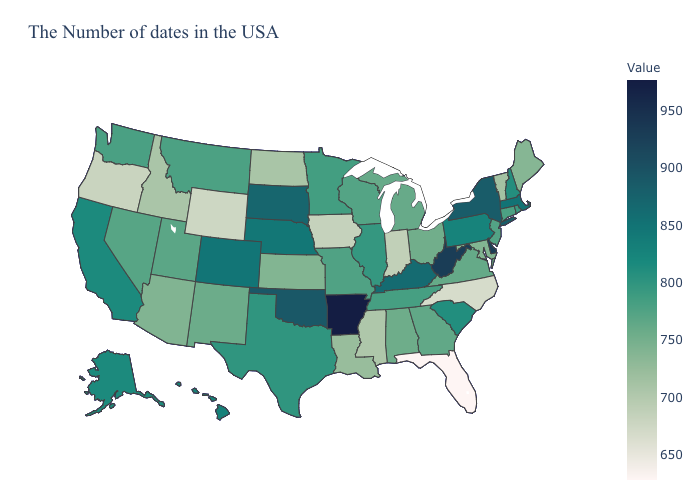Which states have the highest value in the USA?
Be succinct. Arkansas. Does Vermont have the lowest value in the Northeast?
Answer briefly. Yes. Does Minnesota have the highest value in the MidWest?
Keep it brief. No. Does Arkansas have the highest value in the South?
Answer briefly. Yes. 